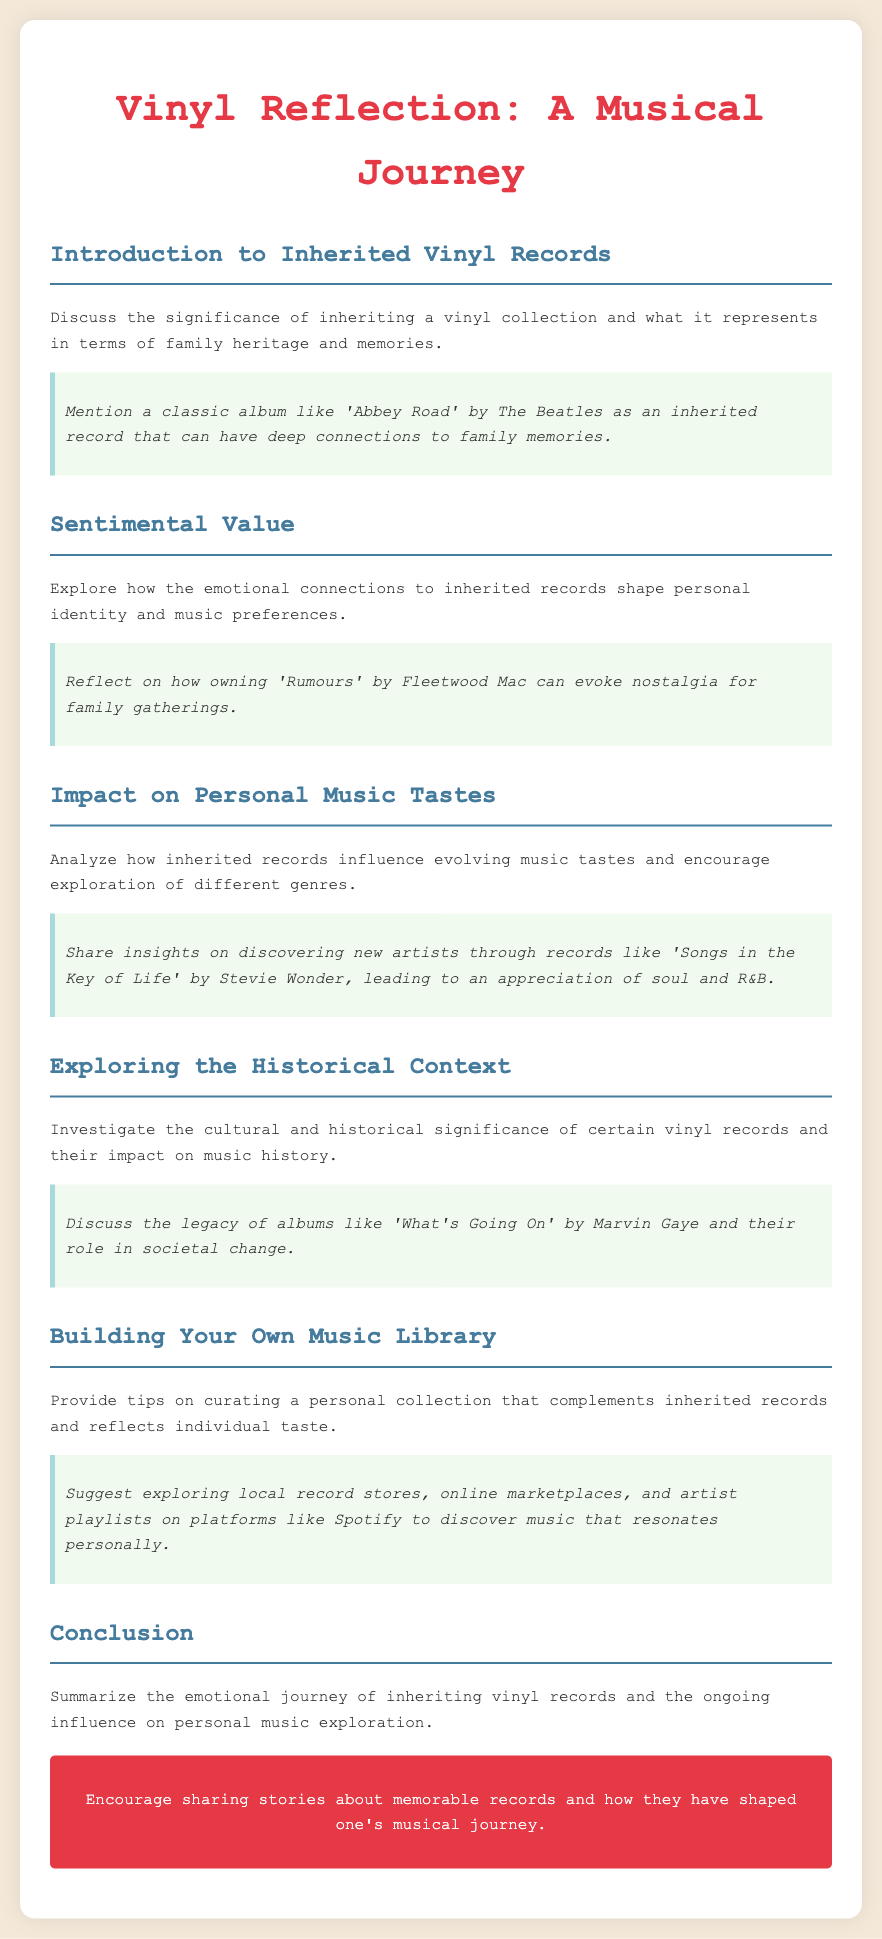What is the title of the document? The title is prominently displayed at the top of the document, labeled "Vinyl Reflection: A Musical Journey."
Answer: Vinyl Reflection: A Musical Journey Which album is mentioned as a classic example of inherited records? The document provides an example of a classic album associated with family memories, specifically "Abbey Road" by The Beatles.
Answer: Abbey Road What emotion does owning 'Rumours' by Fleetwood Mac evoke? The document states that owning this album can evoke nostalgia for family gatherings, highlighting its sentimental value.
Answer: Nostalgia Which artist's album leads to an appreciation of soul and R&B? The document mentions "Songs in the Key of Life" by Stevie Wonder as an album that encourages exploration of different genres, including soul and R&B.
Answer: Stevie Wonder What is suggested for discovering music that resonates personally? The document offers tips for curating a music collection, suggesting that one explore local record stores, online marketplaces, and artist playlists on platforms like Spotify.
Answer: Explore local record stores What is the significance of 'What's Going On' by Marvin Gaye? The document highlights the cultural and historical significance of this album, particularly its role in societal change.
Answer: Societal change What color represents the title of the document? The color of the text used for the title "Vinyl Reflection: A Musical Journey" is specified in the document style as #e63946.
Answer: #e63946 What type of journey does inheriting vinyl records represent? The document summarizes the emotional journey related to music exploration that comes from inheriting vinyl records.
Answer: Emotional journey 